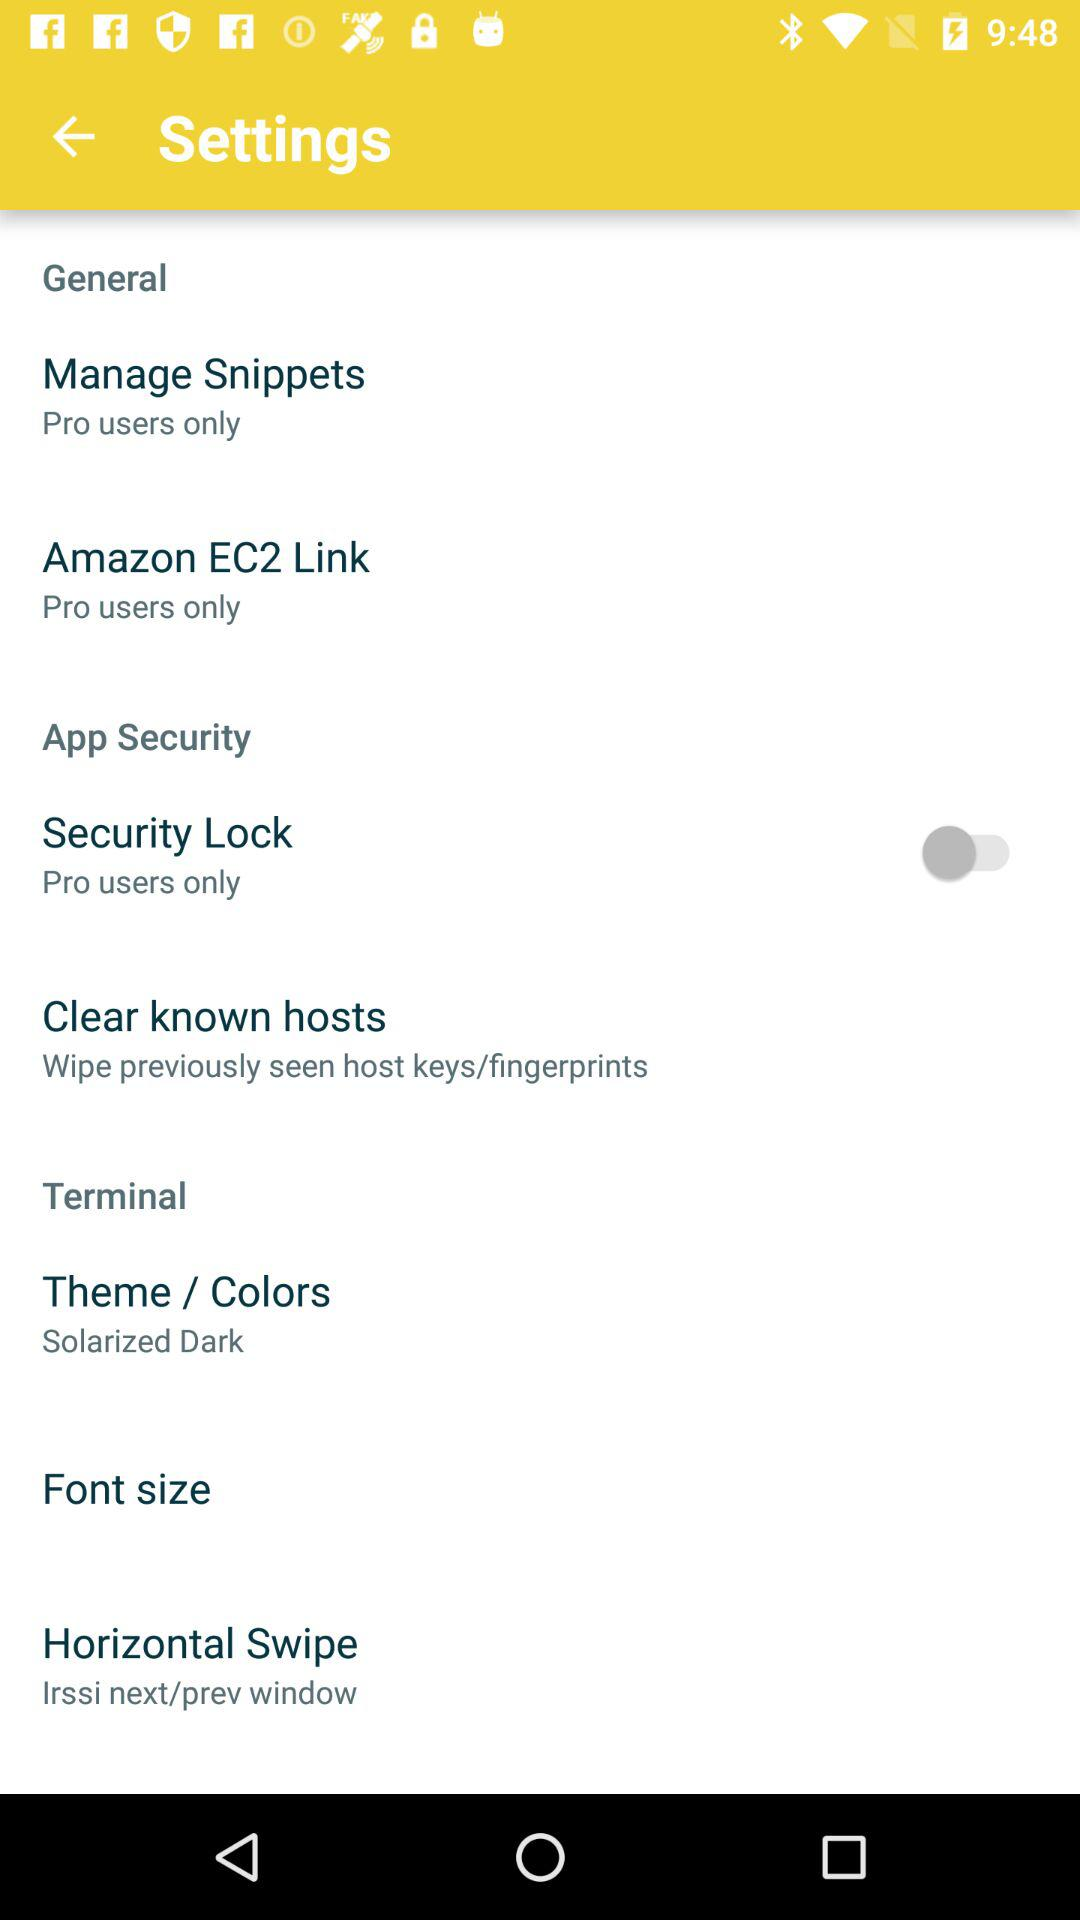How many items are there that are only for pro users?
Answer the question using a single word or phrase. 3 